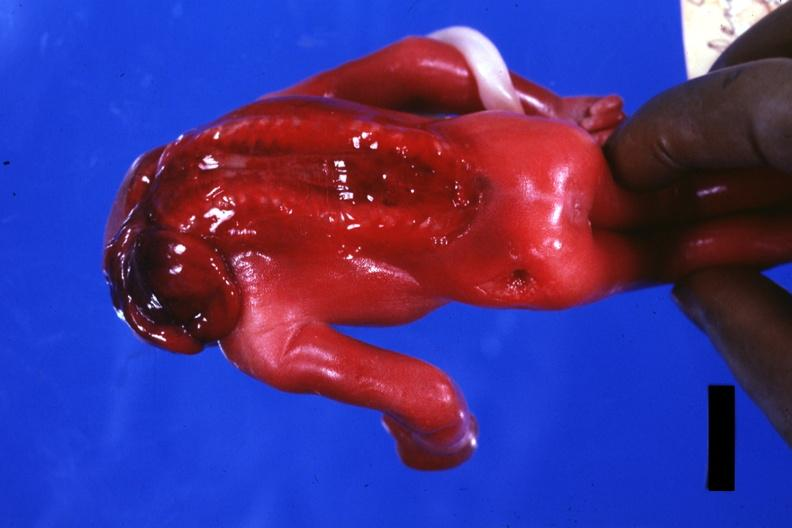s anencephaly present?
Answer the question using a single word or phrase. Yes 